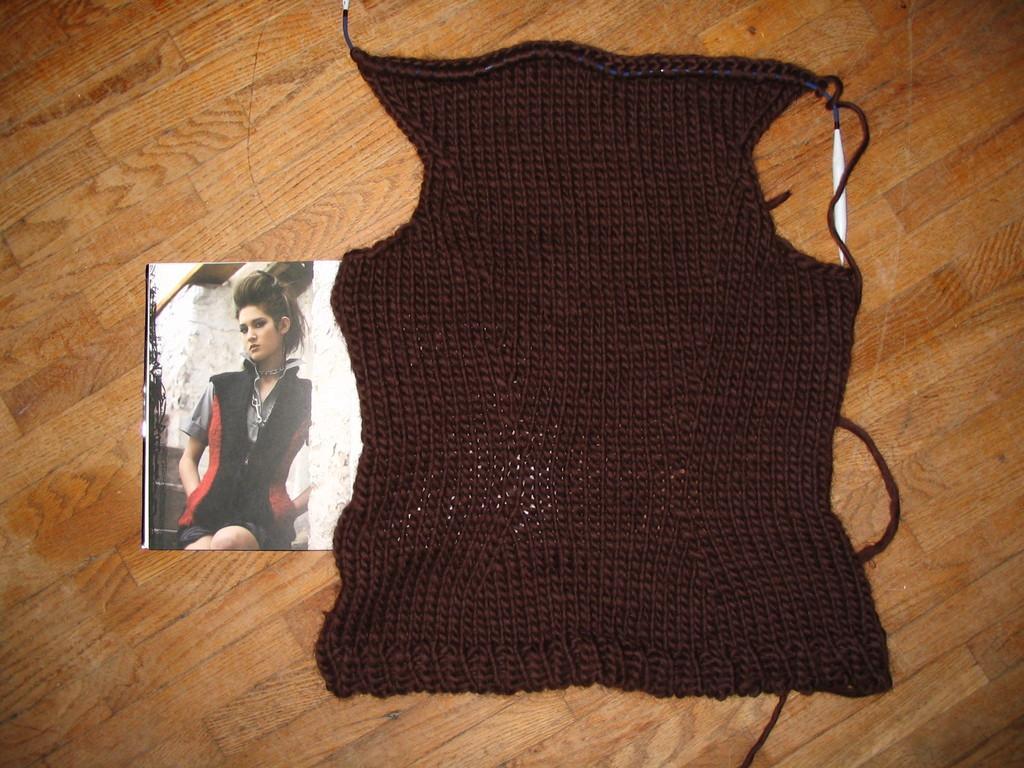Can you describe this image briefly? In this picture we can see a cloth and a photo, at the bottom there is wooden surface, in this photo we can see a girl. 